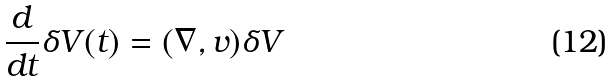Convert formula to latex. <formula><loc_0><loc_0><loc_500><loc_500>\frac { d } { d t } \delta V ( t ) = ( \nabla , v ) \delta V</formula> 